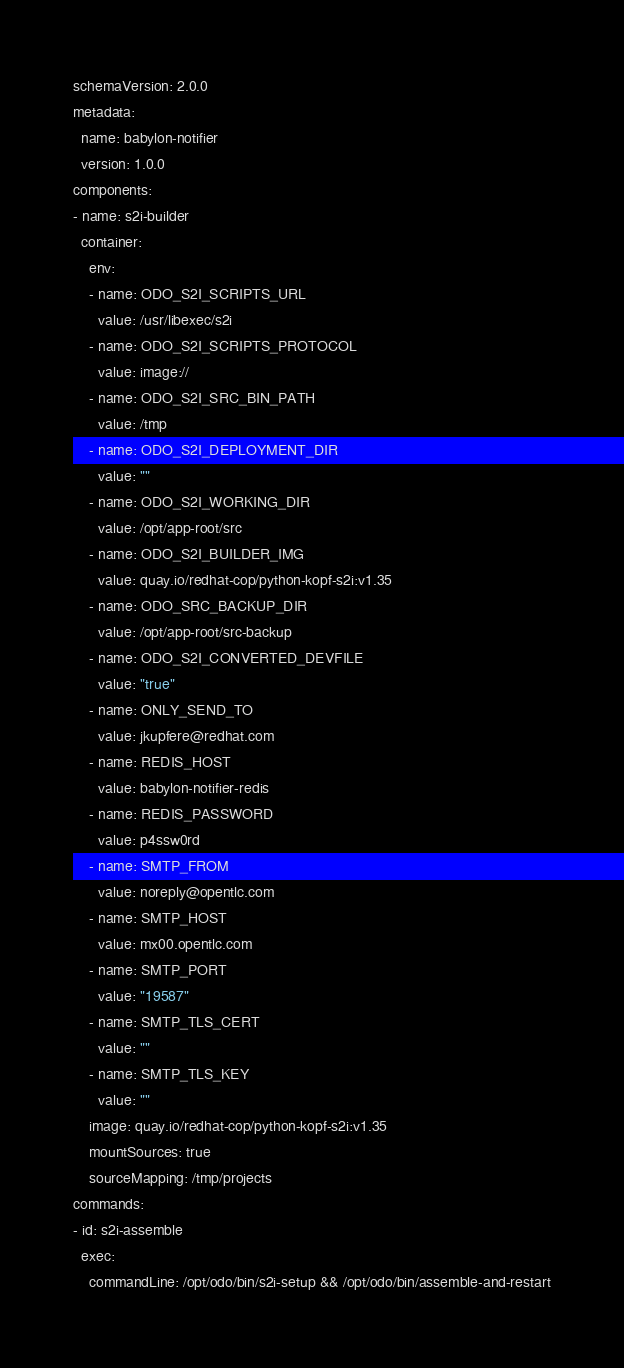<code> <loc_0><loc_0><loc_500><loc_500><_YAML_>schemaVersion: 2.0.0
metadata:
  name: babylon-notifier
  version: 1.0.0
components:
- name: s2i-builder
  container:
    env:
    - name: ODO_S2I_SCRIPTS_URL
      value: /usr/libexec/s2i
    - name: ODO_S2I_SCRIPTS_PROTOCOL
      value: image://
    - name: ODO_S2I_SRC_BIN_PATH
      value: /tmp
    - name: ODO_S2I_DEPLOYMENT_DIR
      value: ""
    - name: ODO_S2I_WORKING_DIR
      value: /opt/app-root/src
    - name: ODO_S2I_BUILDER_IMG
      value: quay.io/redhat-cop/python-kopf-s2i:v1.35
    - name: ODO_SRC_BACKUP_DIR
      value: /opt/app-root/src-backup
    - name: ODO_S2I_CONVERTED_DEVFILE
      value: "true"
    - name: ONLY_SEND_TO
      value: jkupfere@redhat.com
    - name: REDIS_HOST
      value: babylon-notifier-redis
    - name: REDIS_PASSWORD
      value: p4ssw0rd
    - name: SMTP_FROM
      value: noreply@opentlc.com
    - name: SMTP_HOST
      value: mx00.opentlc.com
    - name: SMTP_PORT
      value: "19587"
    - name: SMTP_TLS_CERT
      value: ""
    - name: SMTP_TLS_KEY
      value: ""
    image: quay.io/redhat-cop/python-kopf-s2i:v1.35
    mountSources: true
    sourceMapping: /tmp/projects
commands:
- id: s2i-assemble
  exec:
    commandLine: /opt/odo/bin/s2i-setup && /opt/odo/bin/assemble-and-restart</code> 